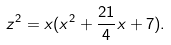<formula> <loc_0><loc_0><loc_500><loc_500>z ^ { 2 } = x ( x ^ { 2 } + \frac { 2 1 } { 4 } x + 7 ) .</formula> 